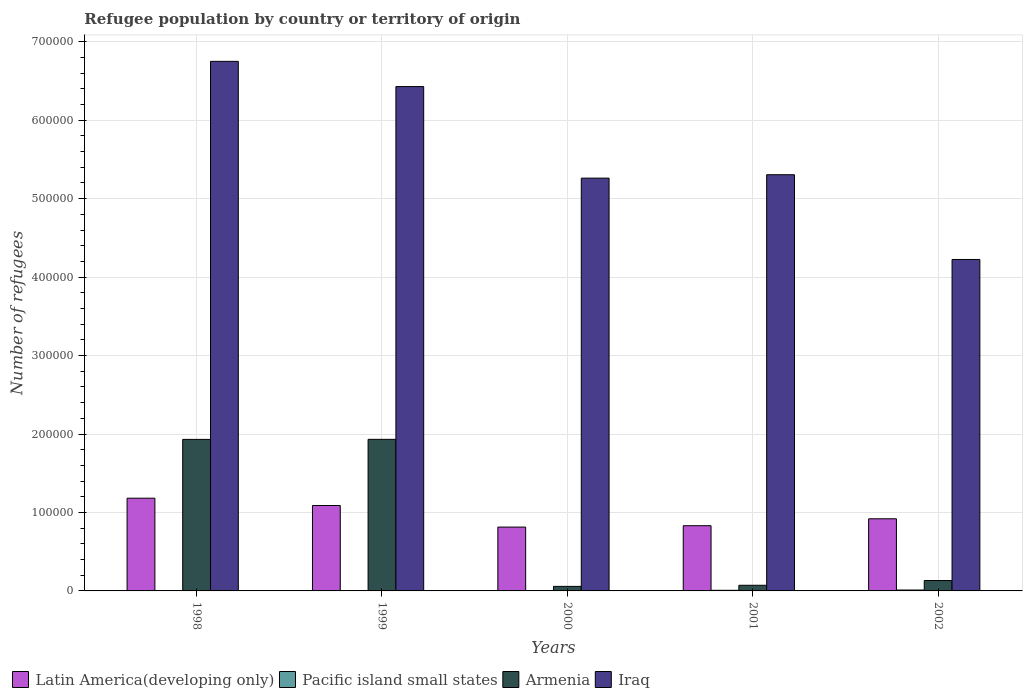How many groups of bars are there?
Provide a short and direct response. 5. How many bars are there on the 4th tick from the left?
Your answer should be very brief. 4. What is the label of the 1st group of bars from the left?
Make the answer very short. 1998. In how many cases, is the number of bars for a given year not equal to the number of legend labels?
Ensure brevity in your answer.  0. What is the number of refugees in Armenia in 2001?
Keep it short and to the point. 7207. Across all years, what is the maximum number of refugees in Armenia?
Provide a succinct answer. 1.93e+05. Across all years, what is the minimum number of refugees in Armenia?
Provide a short and direct response. 5786. In which year was the number of refugees in Latin America(developing only) maximum?
Your response must be concise. 1998. What is the total number of refugees in Iraq in the graph?
Your response must be concise. 2.80e+06. What is the difference between the number of refugees in Armenia in 1998 and that in 1999?
Your answer should be compact. -81. What is the difference between the number of refugees in Latin America(developing only) in 2002 and the number of refugees in Pacific island small states in 1999?
Offer a terse response. 9.16e+04. What is the average number of refugees in Iraq per year?
Your response must be concise. 5.59e+05. In the year 2001, what is the difference between the number of refugees in Armenia and number of refugees in Pacific island small states?
Ensure brevity in your answer.  6429. In how many years, is the number of refugees in Pacific island small states greater than 60000?
Your answer should be compact. 0. What is the ratio of the number of refugees in Armenia in 2001 to that in 2002?
Your response must be concise. 0.54. Is the difference between the number of refugees in Armenia in 1998 and 1999 greater than the difference between the number of refugees in Pacific island small states in 1998 and 1999?
Keep it short and to the point. No. What is the difference between the highest and the second highest number of refugees in Latin America(developing only)?
Provide a short and direct response. 9315. What is the difference between the highest and the lowest number of refugees in Pacific island small states?
Provide a succinct answer. 799. Is the sum of the number of refugees in Latin America(developing only) in 1998 and 2001 greater than the maximum number of refugees in Iraq across all years?
Ensure brevity in your answer.  No. Is it the case that in every year, the sum of the number of refugees in Latin America(developing only) and number of refugees in Armenia is greater than the sum of number of refugees in Pacific island small states and number of refugees in Iraq?
Give a very brief answer. Yes. What does the 4th bar from the left in 2002 represents?
Give a very brief answer. Iraq. What does the 4th bar from the right in 1999 represents?
Ensure brevity in your answer.  Latin America(developing only). What is the difference between two consecutive major ticks on the Y-axis?
Provide a short and direct response. 1.00e+05. Where does the legend appear in the graph?
Provide a succinct answer. Bottom left. What is the title of the graph?
Your answer should be compact. Refugee population by country or territory of origin. What is the label or title of the Y-axis?
Give a very brief answer. Number of refugees. What is the Number of refugees in Latin America(developing only) in 1998?
Offer a very short reply. 1.18e+05. What is the Number of refugees in Pacific island small states in 1998?
Make the answer very short. 341. What is the Number of refugees in Armenia in 1998?
Offer a terse response. 1.93e+05. What is the Number of refugees in Iraq in 1998?
Give a very brief answer. 6.75e+05. What is the Number of refugees in Latin America(developing only) in 1999?
Make the answer very short. 1.09e+05. What is the Number of refugees of Pacific island small states in 1999?
Provide a succinct answer. 368. What is the Number of refugees in Armenia in 1999?
Your answer should be very brief. 1.93e+05. What is the Number of refugees of Iraq in 1999?
Your answer should be very brief. 6.43e+05. What is the Number of refugees in Latin America(developing only) in 2000?
Ensure brevity in your answer.  8.14e+04. What is the Number of refugees in Pacific island small states in 2000?
Keep it short and to the point. 442. What is the Number of refugees of Armenia in 2000?
Provide a succinct answer. 5786. What is the Number of refugees of Iraq in 2000?
Offer a terse response. 5.26e+05. What is the Number of refugees in Latin America(developing only) in 2001?
Offer a very short reply. 8.31e+04. What is the Number of refugees of Pacific island small states in 2001?
Your answer should be compact. 778. What is the Number of refugees of Armenia in 2001?
Your response must be concise. 7207. What is the Number of refugees in Iraq in 2001?
Your response must be concise. 5.31e+05. What is the Number of refugees of Latin America(developing only) in 2002?
Make the answer very short. 9.19e+04. What is the Number of refugees in Pacific island small states in 2002?
Keep it short and to the point. 1140. What is the Number of refugees of Armenia in 2002?
Provide a succinct answer. 1.32e+04. What is the Number of refugees in Iraq in 2002?
Keep it short and to the point. 4.23e+05. Across all years, what is the maximum Number of refugees in Latin America(developing only)?
Provide a succinct answer. 1.18e+05. Across all years, what is the maximum Number of refugees in Pacific island small states?
Provide a succinct answer. 1140. Across all years, what is the maximum Number of refugees in Armenia?
Ensure brevity in your answer.  1.93e+05. Across all years, what is the maximum Number of refugees of Iraq?
Your answer should be compact. 6.75e+05. Across all years, what is the minimum Number of refugees in Latin America(developing only)?
Give a very brief answer. 8.14e+04. Across all years, what is the minimum Number of refugees of Pacific island small states?
Keep it short and to the point. 341. Across all years, what is the minimum Number of refugees of Armenia?
Provide a short and direct response. 5786. Across all years, what is the minimum Number of refugees in Iraq?
Your response must be concise. 4.23e+05. What is the total Number of refugees in Latin America(developing only) in the graph?
Your answer should be compact. 4.83e+05. What is the total Number of refugees of Pacific island small states in the graph?
Ensure brevity in your answer.  3069. What is the total Number of refugees of Armenia in the graph?
Ensure brevity in your answer.  4.13e+05. What is the total Number of refugees in Iraq in the graph?
Your answer should be compact. 2.80e+06. What is the difference between the Number of refugees in Latin America(developing only) in 1998 and that in 1999?
Ensure brevity in your answer.  9315. What is the difference between the Number of refugees of Armenia in 1998 and that in 1999?
Offer a terse response. -81. What is the difference between the Number of refugees in Iraq in 1998 and that in 1999?
Ensure brevity in your answer.  3.21e+04. What is the difference between the Number of refugees in Latin America(developing only) in 1998 and that in 2000?
Your response must be concise. 3.68e+04. What is the difference between the Number of refugees in Pacific island small states in 1998 and that in 2000?
Offer a very short reply. -101. What is the difference between the Number of refugees in Armenia in 1998 and that in 2000?
Provide a short and direct response. 1.87e+05. What is the difference between the Number of refugees of Iraq in 1998 and that in 2000?
Your answer should be compact. 1.49e+05. What is the difference between the Number of refugees in Latin America(developing only) in 1998 and that in 2001?
Keep it short and to the point. 3.51e+04. What is the difference between the Number of refugees of Pacific island small states in 1998 and that in 2001?
Keep it short and to the point. -437. What is the difference between the Number of refugees in Armenia in 1998 and that in 2001?
Your response must be concise. 1.86e+05. What is the difference between the Number of refugees of Iraq in 1998 and that in 2001?
Offer a terse response. 1.45e+05. What is the difference between the Number of refugees of Latin America(developing only) in 1998 and that in 2002?
Your answer should be compact. 2.62e+04. What is the difference between the Number of refugees in Pacific island small states in 1998 and that in 2002?
Give a very brief answer. -799. What is the difference between the Number of refugees of Armenia in 1998 and that in 2002?
Ensure brevity in your answer.  1.80e+05. What is the difference between the Number of refugees of Iraq in 1998 and that in 2002?
Provide a succinct answer. 2.53e+05. What is the difference between the Number of refugees in Latin America(developing only) in 1999 and that in 2000?
Offer a terse response. 2.75e+04. What is the difference between the Number of refugees in Pacific island small states in 1999 and that in 2000?
Make the answer very short. -74. What is the difference between the Number of refugees of Armenia in 1999 and that in 2000?
Your answer should be compact. 1.87e+05. What is the difference between the Number of refugees of Iraq in 1999 and that in 2000?
Keep it short and to the point. 1.17e+05. What is the difference between the Number of refugees in Latin America(developing only) in 1999 and that in 2001?
Offer a terse response. 2.58e+04. What is the difference between the Number of refugees of Pacific island small states in 1999 and that in 2001?
Offer a very short reply. -410. What is the difference between the Number of refugees in Armenia in 1999 and that in 2001?
Provide a succinct answer. 1.86e+05. What is the difference between the Number of refugees of Iraq in 1999 and that in 2001?
Keep it short and to the point. 1.12e+05. What is the difference between the Number of refugees of Latin America(developing only) in 1999 and that in 2002?
Keep it short and to the point. 1.69e+04. What is the difference between the Number of refugees in Pacific island small states in 1999 and that in 2002?
Your response must be concise. -772. What is the difference between the Number of refugees in Armenia in 1999 and that in 2002?
Ensure brevity in your answer.  1.80e+05. What is the difference between the Number of refugees of Iraq in 1999 and that in 2002?
Provide a short and direct response. 2.20e+05. What is the difference between the Number of refugees in Latin America(developing only) in 2000 and that in 2001?
Give a very brief answer. -1758. What is the difference between the Number of refugees of Pacific island small states in 2000 and that in 2001?
Ensure brevity in your answer.  -336. What is the difference between the Number of refugees of Armenia in 2000 and that in 2001?
Ensure brevity in your answer.  -1421. What is the difference between the Number of refugees in Iraq in 2000 and that in 2001?
Make the answer very short. -4332. What is the difference between the Number of refugees of Latin America(developing only) in 2000 and that in 2002?
Offer a very short reply. -1.06e+04. What is the difference between the Number of refugees of Pacific island small states in 2000 and that in 2002?
Your response must be concise. -698. What is the difference between the Number of refugees of Armenia in 2000 and that in 2002?
Give a very brief answer. -7463. What is the difference between the Number of refugees of Iraq in 2000 and that in 2002?
Provide a short and direct response. 1.04e+05. What is the difference between the Number of refugees of Latin America(developing only) in 2001 and that in 2002?
Offer a terse response. -8815. What is the difference between the Number of refugees in Pacific island small states in 2001 and that in 2002?
Give a very brief answer. -362. What is the difference between the Number of refugees in Armenia in 2001 and that in 2002?
Give a very brief answer. -6042. What is the difference between the Number of refugees of Iraq in 2001 and that in 2002?
Your response must be concise. 1.08e+05. What is the difference between the Number of refugees of Latin America(developing only) in 1998 and the Number of refugees of Pacific island small states in 1999?
Ensure brevity in your answer.  1.18e+05. What is the difference between the Number of refugees in Latin America(developing only) in 1998 and the Number of refugees in Armenia in 1999?
Your response must be concise. -7.50e+04. What is the difference between the Number of refugees of Latin America(developing only) in 1998 and the Number of refugees of Iraq in 1999?
Ensure brevity in your answer.  -5.25e+05. What is the difference between the Number of refugees in Pacific island small states in 1998 and the Number of refugees in Armenia in 1999?
Your answer should be very brief. -1.93e+05. What is the difference between the Number of refugees of Pacific island small states in 1998 and the Number of refugees of Iraq in 1999?
Your answer should be compact. -6.43e+05. What is the difference between the Number of refugees of Armenia in 1998 and the Number of refugees of Iraq in 1999?
Offer a very short reply. -4.50e+05. What is the difference between the Number of refugees of Latin America(developing only) in 1998 and the Number of refugees of Pacific island small states in 2000?
Your answer should be very brief. 1.18e+05. What is the difference between the Number of refugees of Latin America(developing only) in 1998 and the Number of refugees of Armenia in 2000?
Your answer should be compact. 1.12e+05. What is the difference between the Number of refugees in Latin America(developing only) in 1998 and the Number of refugees in Iraq in 2000?
Provide a short and direct response. -4.08e+05. What is the difference between the Number of refugees of Pacific island small states in 1998 and the Number of refugees of Armenia in 2000?
Keep it short and to the point. -5445. What is the difference between the Number of refugees in Pacific island small states in 1998 and the Number of refugees in Iraq in 2000?
Your response must be concise. -5.26e+05. What is the difference between the Number of refugees of Armenia in 1998 and the Number of refugees of Iraq in 2000?
Your answer should be very brief. -3.33e+05. What is the difference between the Number of refugees of Latin America(developing only) in 1998 and the Number of refugees of Pacific island small states in 2001?
Your answer should be very brief. 1.17e+05. What is the difference between the Number of refugees in Latin America(developing only) in 1998 and the Number of refugees in Armenia in 2001?
Your answer should be very brief. 1.11e+05. What is the difference between the Number of refugees in Latin America(developing only) in 1998 and the Number of refugees in Iraq in 2001?
Provide a short and direct response. -4.12e+05. What is the difference between the Number of refugees in Pacific island small states in 1998 and the Number of refugees in Armenia in 2001?
Provide a succinct answer. -6866. What is the difference between the Number of refugees of Pacific island small states in 1998 and the Number of refugees of Iraq in 2001?
Keep it short and to the point. -5.30e+05. What is the difference between the Number of refugees in Armenia in 1998 and the Number of refugees in Iraq in 2001?
Offer a terse response. -3.37e+05. What is the difference between the Number of refugees in Latin America(developing only) in 1998 and the Number of refugees in Pacific island small states in 2002?
Your response must be concise. 1.17e+05. What is the difference between the Number of refugees in Latin America(developing only) in 1998 and the Number of refugees in Armenia in 2002?
Give a very brief answer. 1.05e+05. What is the difference between the Number of refugees of Latin America(developing only) in 1998 and the Number of refugees of Iraq in 2002?
Make the answer very short. -3.04e+05. What is the difference between the Number of refugees of Pacific island small states in 1998 and the Number of refugees of Armenia in 2002?
Make the answer very short. -1.29e+04. What is the difference between the Number of refugees of Pacific island small states in 1998 and the Number of refugees of Iraq in 2002?
Ensure brevity in your answer.  -4.22e+05. What is the difference between the Number of refugees of Armenia in 1998 and the Number of refugees of Iraq in 2002?
Offer a terse response. -2.29e+05. What is the difference between the Number of refugees of Latin America(developing only) in 1999 and the Number of refugees of Pacific island small states in 2000?
Offer a very short reply. 1.08e+05. What is the difference between the Number of refugees of Latin America(developing only) in 1999 and the Number of refugees of Armenia in 2000?
Provide a succinct answer. 1.03e+05. What is the difference between the Number of refugees in Latin America(developing only) in 1999 and the Number of refugees in Iraq in 2000?
Give a very brief answer. -4.17e+05. What is the difference between the Number of refugees in Pacific island small states in 1999 and the Number of refugees in Armenia in 2000?
Your response must be concise. -5418. What is the difference between the Number of refugees in Pacific island small states in 1999 and the Number of refugees in Iraq in 2000?
Keep it short and to the point. -5.26e+05. What is the difference between the Number of refugees of Armenia in 1999 and the Number of refugees of Iraq in 2000?
Ensure brevity in your answer.  -3.33e+05. What is the difference between the Number of refugees of Latin America(developing only) in 1999 and the Number of refugees of Pacific island small states in 2001?
Keep it short and to the point. 1.08e+05. What is the difference between the Number of refugees of Latin America(developing only) in 1999 and the Number of refugees of Armenia in 2001?
Your answer should be very brief. 1.02e+05. What is the difference between the Number of refugees of Latin America(developing only) in 1999 and the Number of refugees of Iraq in 2001?
Offer a very short reply. -4.22e+05. What is the difference between the Number of refugees in Pacific island small states in 1999 and the Number of refugees in Armenia in 2001?
Your response must be concise. -6839. What is the difference between the Number of refugees of Pacific island small states in 1999 and the Number of refugees of Iraq in 2001?
Provide a succinct answer. -5.30e+05. What is the difference between the Number of refugees of Armenia in 1999 and the Number of refugees of Iraq in 2001?
Make the answer very short. -3.37e+05. What is the difference between the Number of refugees of Latin America(developing only) in 1999 and the Number of refugees of Pacific island small states in 2002?
Offer a very short reply. 1.08e+05. What is the difference between the Number of refugees of Latin America(developing only) in 1999 and the Number of refugees of Armenia in 2002?
Your response must be concise. 9.56e+04. What is the difference between the Number of refugees of Latin America(developing only) in 1999 and the Number of refugees of Iraq in 2002?
Give a very brief answer. -3.14e+05. What is the difference between the Number of refugees in Pacific island small states in 1999 and the Number of refugees in Armenia in 2002?
Offer a terse response. -1.29e+04. What is the difference between the Number of refugees of Pacific island small states in 1999 and the Number of refugees of Iraq in 2002?
Make the answer very short. -4.22e+05. What is the difference between the Number of refugees in Armenia in 1999 and the Number of refugees in Iraq in 2002?
Your answer should be compact. -2.29e+05. What is the difference between the Number of refugees of Latin America(developing only) in 2000 and the Number of refugees of Pacific island small states in 2001?
Provide a succinct answer. 8.06e+04. What is the difference between the Number of refugees of Latin America(developing only) in 2000 and the Number of refugees of Armenia in 2001?
Provide a succinct answer. 7.42e+04. What is the difference between the Number of refugees in Latin America(developing only) in 2000 and the Number of refugees in Iraq in 2001?
Ensure brevity in your answer.  -4.49e+05. What is the difference between the Number of refugees of Pacific island small states in 2000 and the Number of refugees of Armenia in 2001?
Provide a short and direct response. -6765. What is the difference between the Number of refugees in Pacific island small states in 2000 and the Number of refugees in Iraq in 2001?
Your response must be concise. -5.30e+05. What is the difference between the Number of refugees in Armenia in 2000 and the Number of refugees in Iraq in 2001?
Give a very brief answer. -5.25e+05. What is the difference between the Number of refugees of Latin America(developing only) in 2000 and the Number of refugees of Pacific island small states in 2002?
Provide a succinct answer. 8.02e+04. What is the difference between the Number of refugees in Latin America(developing only) in 2000 and the Number of refugees in Armenia in 2002?
Offer a very short reply. 6.81e+04. What is the difference between the Number of refugees in Latin America(developing only) in 2000 and the Number of refugees in Iraq in 2002?
Keep it short and to the point. -3.41e+05. What is the difference between the Number of refugees in Pacific island small states in 2000 and the Number of refugees in Armenia in 2002?
Give a very brief answer. -1.28e+04. What is the difference between the Number of refugees in Pacific island small states in 2000 and the Number of refugees in Iraq in 2002?
Your response must be concise. -4.22e+05. What is the difference between the Number of refugees in Armenia in 2000 and the Number of refugees in Iraq in 2002?
Offer a terse response. -4.17e+05. What is the difference between the Number of refugees of Latin America(developing only) in 2001 and the Number of refugees of Pacific island small states in 2002?
Give a very brief answer. 8.20e+04. What is the difference between the Number of refugees in Latin America(developing only) in 2001 and the Number of refugees in Armenia in 2002?
Offer a terse response. 6.99e+04. What is the difference between the Number of refugees of Latin America(developing only) in 2001 and the Number of refugees of Iraq in 2002?
Offer a very short reply. -3.39e+05. What is the difference between the Number of refugees of Pacific island small states in 2001 and the Number of refugees of Armenia in 2002?
Keep it short and to the point. -1.25e+04. What is the difference between the Number of refugees of Pacific island small states in 2001 and the Number of refugees of Iraq in 2002?
Make the answer very short. -4.22e+05. What is the difference between the Number of refugees of Armenia in 2001 and the Number of refugees of Iraq in 2002?
Provide a succinct answer. -4.15e+05. What is the average Number of refugees of Latin America(developing only) per year?
Offer a very short reply. 9.67e+04. What is the average Number of refugees in Pacific island small states per year?
Give a very brief answer. 613.8. What is the average Number of refugees of Armenia per year?
Make the answer very short. 8.25e+04. What is the average Number of refugees in Iraq per year?
Keep it short and to the point. 5.59e+05. In the year 1998, what is the difference between the Number of refugees of Latin America(developing only) and Number of refugees of Pacific island small states?
Provide a short and direct response. 1.18e+05. In the year 1998, what is the difference between the Number of refugees in Latin America(developing only) and Number of refugees in Armenia?
Provide a short and direct response. -7.50e+04. In the year 1998, what is the difference between the Number of refugees in Latin America(developing only) and Number of refugees in Iraq?
Your answer should be compact. -5.57e+05. In the year 1998, what is the difference between the Number of refugees in Pacific island small states and Number of refugees in Armenia?
Make the answer very short. -1.93e+05. In the year 1998, what is the difference between the Number of refugees of Pacific island small states and Number of refugees of Iraq?
Make the answer very short. -6.75e+05. In the year 1998, what is the difference between the Number of refugees of Armenia and Number of refugees of Iraq?
Your response must be concise. -4.82e+05. In the year 1999, what is the difference between the Number of refugees in Latin America(developing only) and Number of refugees in Pacific island small states?
Give a very brief answer. 1.09e+05. In the year 1999, what is the difference between the Number of refugees of Latin America(developing only) and Number of refugees of Armenia?
Your response must be concise. -8.44e+04. In the year 1999, what is the difference between the Number of refugees of Latin America(developing only) and Number of refugees of Iraq?
Provide a short and direct response. -5.34e+05. In the year 1999, what is the difference between the Number of refugees in Pacific island small states and Number of refugees in Armenia?
Your answer should be very brief. -1.93e+05. In the year 1999, what is the difference between the Number of refugees in Pacific island small states and Number of refugees in Iraq?
Provide a succinct answer. -6.43e+05. In the year 1999, what is the difference between the Number of refugees in Armenia and Number of refugees in Iraq?
Keep it short and to the point. -4.50e+05. In the year 2000, what is the difference between the Number of refugees in Latin America(developing only) and Number of refugees in Pacific island small states?
Keep it short and to the point. 8.09e+04. In the year 2000, what is the difference between the Number of refugees of Latin America(developing only) and Number of refugees of Armenia?
Offer a very short reply. 7.56e+04. In the year 2000, what is the difference between the Number of refugees of Latin America(developing only) and Number of refugees of Iraq?
Provide a short and direct response. -4.45e+05. In the year 2000, what is the difference between the Number of refugees in Pacific island small states and Number of refugees in Armenia?
Give a very brief answer. -5344. In the year 2000, what is the difference between the Number of refugees in Pacific island small states and Number of refugees in Iraq?
Keep it short and to the point. -5.26e+05. In the year 2000, what is the difference between the Number of refugees in Armenia and Number of refugees in Iraq?
Provide a succinct answer. -5.20e+05. In the year 2001, what is the difference between the Number of refugees of Latin America(developing only) and Number of refugees of Pacific island small states?
Give a very brief answer. 8.23e+04. In the year 2001, what is the difference between the Number of refugees of Latin America(developing only) and Number of refugees of Armenia?
Your response must be concise. 7.59e+04. In the year 2001, what is the difference between the Number of refugees in Latin America(developing only) and Number of refugees in Iraq?
Keep it short and to the point. -4.47e+05. In the year 2001, what is the difference between the Number of refugees of Pacific island small states and Number of refugees of Armenia?
Provide a succinct answer. -6429. In the year 2001, what is the difference between the Number of refugees in Pacific island small states and Number of refugees in Iraq?
Ensure brevity in your answer.  -5.30e+05. In the year 2001, what is the difference between the Number of refugees in Armenia and Number of refugees in Iraq?
Give a very brief answer. -5.23e+05. In the year 2002, what is the difference between the Number of refugees of Latin America(developing only) and Number of refugees of Pacific island small states?
Your response must be concise. 9.08e+04. In the year 2002, what is the difference between the Number of refugees of Latin America(developing only) and Number of refugees of Armenia?
Make the answer very short. 7.87e+04. In the year 2002, what is the difference between the Number of refugees of Latin America(developing only) and Number of refugees of Iraq?
Provide a succinct answer. -3.31e+05. In the year 2002, what is the difference between the Number of refugees of Pacific island small states and Number of refugees of Armenia?
Offer a terse response. -1.21e+04. In the year 2002, what is the difference between the Number of refugees of Pacific island small states and Number of refugees of Iraq?
Provide a short and direct response. -4.21e+05. In the year 2002, what is the difference between the Number of refugees in Armenia and Number of refugees in Iraq?
Give a very brief answer. -4.09e+05. What is the ratio of the Number of refugees of Latin America(developing only) in 1998 to that in 1999?
Your answer should be compact. 1.09. What is the ratio of the Number of refugees in Pacific island small states in 1998 to that in 1999?
Your answer should be compact. 0.93. What is the ratio of the Number of refugees in Latin America(developing only) in 1998 to that in 2000?
Ensure brevity in your answer.  1.45. What is the ratio of the Number of refugees of Pacific island small states in 1998 to that in 2000?
Your response must be concise. 0.77. What is the ratio of the Number of refugees in Armenia in 1998 to that in 2000?
Ensure brevity in your answer.  33.38. What is the ratio of the Number of refugees of Iraq in 1998 to that in 2000?
Make the answer very short. 1.28. What is the ratio of the Number of refugees of Latin America(developing only) in 1998 to that in 2001?
Provide a succinct answer. 1.42. What is the ratio of the Number of refugees of Pacific island small states in 1998 to that in 2001?
Offer a very short reply. 0.44. What is the ratio of the Number of refugees in Armenia in 1998 to that in 2001?
Offer a terse response. 26.8. What is the ratio of the Number of refugees of Iraq in 1998 to that in 2001?
Your answer should be compact. 1.27. What is the ratio of the Number of refugees of Latin America(developing only) in 1998 to that in 2002?
Offer a terse response. 1.29. What is the ratio of the Number of refugees in Pacific island small states in 1998 to that in 2002?
Provide a succinct answer. 0.3. What is the ratio of the Number of refugees in Armenia in 1998 to that in 2002?
Give a very brief answer. 14.58. What is the ratio of the Number of refugees in Iraq in 1998 to that in 2002?
Offer a very short reply. 1.6. What is the ratio of the Number of refugees of Latin America(developing only) in 1999 to that in 2000?
Provide a succinct answer. 1.34. What is the ratio of the Number of refugees of Pacific island small states in 1999 to that in 2000?
Provide a short and direct response. 0.83. What is the ratio of the Number of refugees in Armenia in 1999 to that in 2000?
Offer a terse response. 33.4. What is the ratio of the Number of refugees in Iraq in 1999 to that in 2000?
Your answer should be very brief. 1.22. What is the ratio of the Number of refugees in Latin America(developing only) in 1999 to that in 2001?
Offer a very short reply. 1.31. What is the ratio of the Number of refugees in Pacific island small states in 1999 to that in 2001?
Give a very brief answer. 0.47. What is the ratio of the Number of refugees in Armenia in 1999 to that in 2001?
Keep it short and to the point. 26.81. What is the ratio of the Number of refugees in Iraq in 1999 to that in 2001?
Provide a succinct answer. 1.21. What is the ratio of the Number of refugees in Latin America(developing only) in 1999 to that in 2002?
Your answer should be compact. 1.18. What is the ratio of the Number of refugees of Pacific island small states in 1999 to that in 2002?
Offer a very short reply. 0.32. What is the ratio of the Number of refugees of Armenia in 1999 to that in 2002?
Provide a succinct answer. 14.58. What is the ratio of the Number of refugees in Iraq in 1999 to that in 2002?
Offer a very short reply. 1.52. What is the ratio of the Number of refugees of Latin America(developing only) in 2000 to that in 2001?
Provide a succinct answer. 0.98. What is the ratio of the Number of refugees of Pacific island small states in 2000 to that in 2001?
Your answer should be compact. 0.57. What is the ratio of the Number of refugees of Armenia in 2000 to that in 2001?
Offer a terse response. 0.8. What is the ratio of the Number of refugees of Latin America(developing only) in 2000 to that in 2002?
Your answer should be very brief. 0.89. What is the ratio of the Number of refugees in Pacific island small states in 2000 to that in 2002?
Keep it short and to the point. 0.39. What is the ratio of the Number of refugees of Armenia in 2000 to that in 2002?
Give a very brief answer. 0.44. What is the ratio of the Number of refugees of Iraq in 2000 to that in 2002?
Your response must be concise. 1.25. What is the ratio of the Number of refugees of Latin America(developing only) in 2001 to that in 2002?
Your response must be concise. 0.9. What is the ratio of the Number of refugees in Pacific island small states in 2001 to that in 2002?
Provide a short and direct response. 0.68. What is the ratio of the Number of refugees of Armenia in 2001 to that in 2002?
Offer a terse response. 0.54. What is the ratio of the Number of refugees of Iraq in 2001 to that in 2002?
Ensure brevity in your answer.  1.26. What is the difference between the highest and the second highest Number of refugees in Latin America(developing only)?
Keep it short and to the point. 9315. What is the difference between the highest and the second highest Number of refugees in Pacific island small states?
Provide a succinct answer. 362. What is the difference between the highest and the second highest Number of refugees in Iraq?
Your answer should be very brief. 3.21e+04. What is the difference between the highest and the lowest Number of refugees of Latin America(developing only)?
Provide a short and direct response. 3.68e+04. What is the difference between the highest and the lowest Number of refugees of Pacific island small states?
Your response must be concise. 799. What is the difference between the highest and the lowest Number of refugees of Armenia?
Your response must be concise. 1.87e+05. What is the difference between the highest and the lowest Number of refugees of Iraq?
Ensure brevity in your answer.  2.53e+05. 